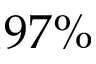<formula> <loc_0><loc_0><loc_500><loc_500>9 7 \%</formula> 